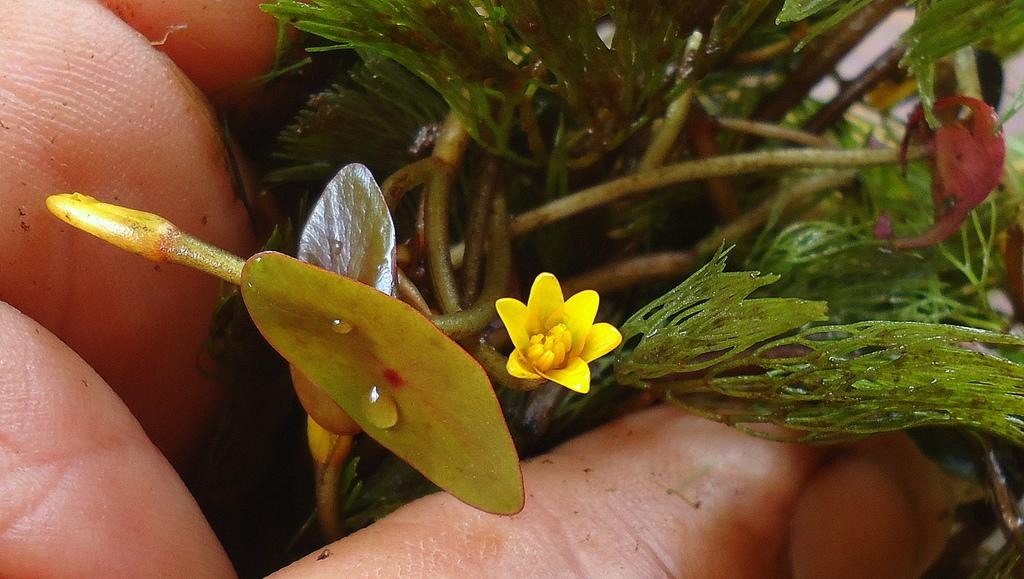What can be seen on the fingers in the image? The facts provided do not specify any details about the fingers, so we cannot determine what is on them. What is the main subject in the center of the image? There is a yellow flower in the center of the image. What is the current stage of the plant's growth in the image? There is a bud on the plant in the image, indicating that it is in the early stages of growth. What type of flag is being waved during the discussion in the image? There is no flag or discussion present in the image; it features a yellow flower and a plant with a bud. 